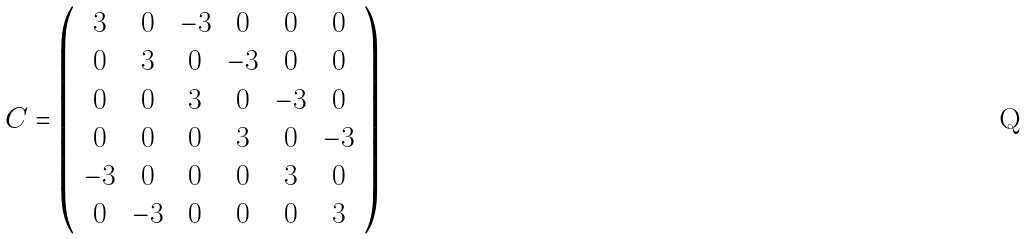Convert formula to latex. <formula><loc_0><loc_0><loc_500><loc_500>C = \left ( \begin{array} { c c c c c c } 3 & 0 & - 3 & 0 & 0 & 0 \\ 0 & 3 & 0 & - 3 & 0 & 0 \\ 0 & 0 & 3 & 0 & - 3 & 0 \\ 0 & 0 & 0 & 3 & 0 & - 3 \\ - 3 & 0 & 0 & 0 & 3 & 0 \\ 0 & - 3 & 0 & 0 & 0 & 3 \end{array} \right )</formula> 